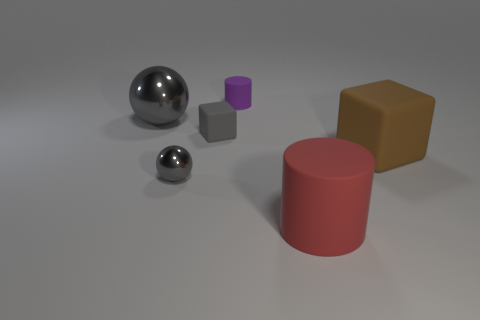Add 1 small purple rubber cylinders. How many objects exist? 7 Subtract all red cylinders. How many cylinders are left? 1 Subtract all spheres. How many objects are left? 4 Subtract 2 cubes. How many cubes are left? 0 Subtract all brown balls. Subtract all green blocks. How many balls are left? 2 Subtract all yellow blocks. How many purple cylinders are left? 1 Subtract all small objects. Subtract all large blocks. How many objects are left? 2 Add 6 gray metal things. How many gray metal things are left? 8 Add 2 red matte things. How many red matte things exist? 3 Subtract 0 cyan cubes. How many objects are left? 6 